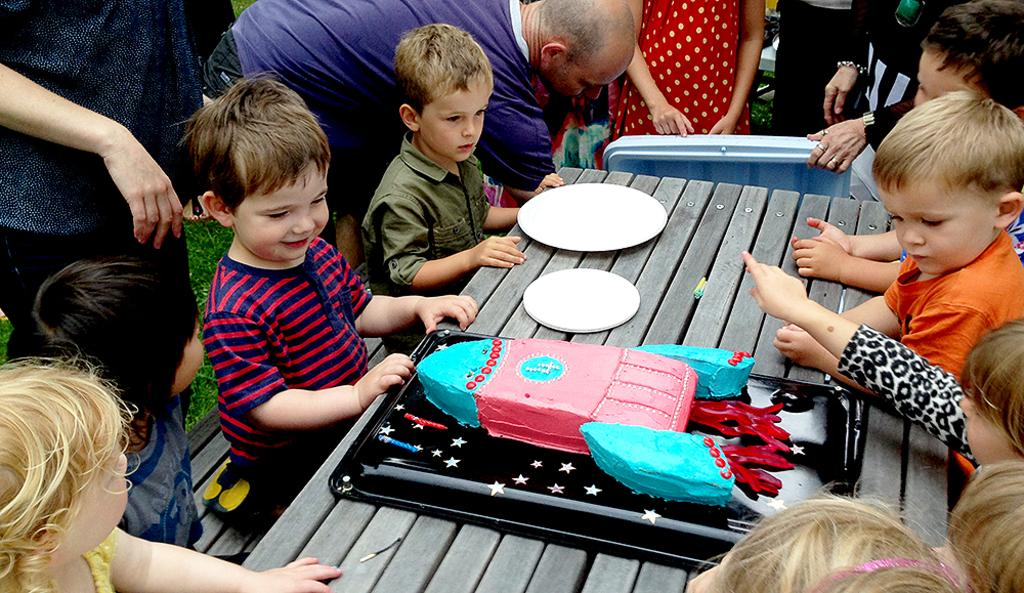Who is present in the image? There are children in the image. What are the children doing in the image? The children are sitting around a table. What is on the table with the children? There is a cake on the table. How many plates are on the table? There are two plates on the table. What is the prison sentence for the example of a child in the image? There is no prison or sentence mentioned in the image; it features children sitting around a table with a cake and two plates. 